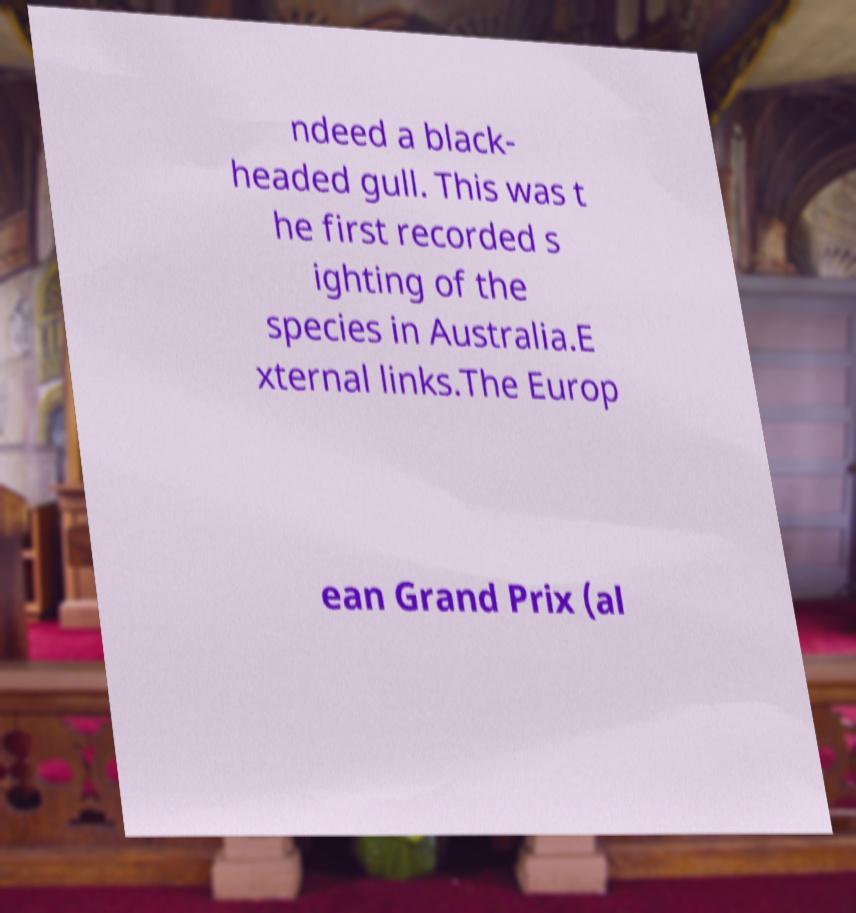Can you accurately transcribe the text from the provided image for me? ndeed a black- headed gull. This was t he first recorded s ighting of the species in Australia.E xternal links.The Europ ean Grand Prix (al 